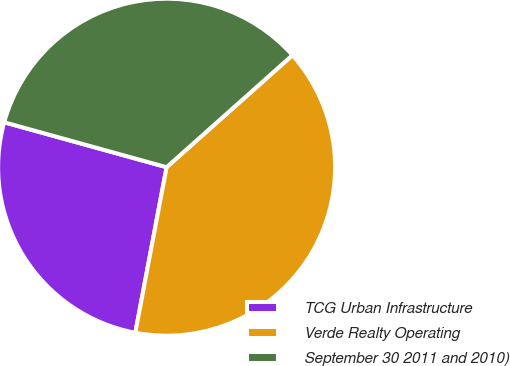Convert chart. <chart><loc_0><loc_0><loc_500><loc_500><pie_chart><fcel>TCG Urban Infrastructure<fcel>Verde Realty Operating<fcel>September 30 2011 and 2010)<nl><fcel>26.32%<fcel>39.55%<fcel>34.13%<nl></chart> 